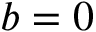Convert formula to latex. <formula><loc_0><loc_0><loc_500><loc_500>b = 0</formula> 